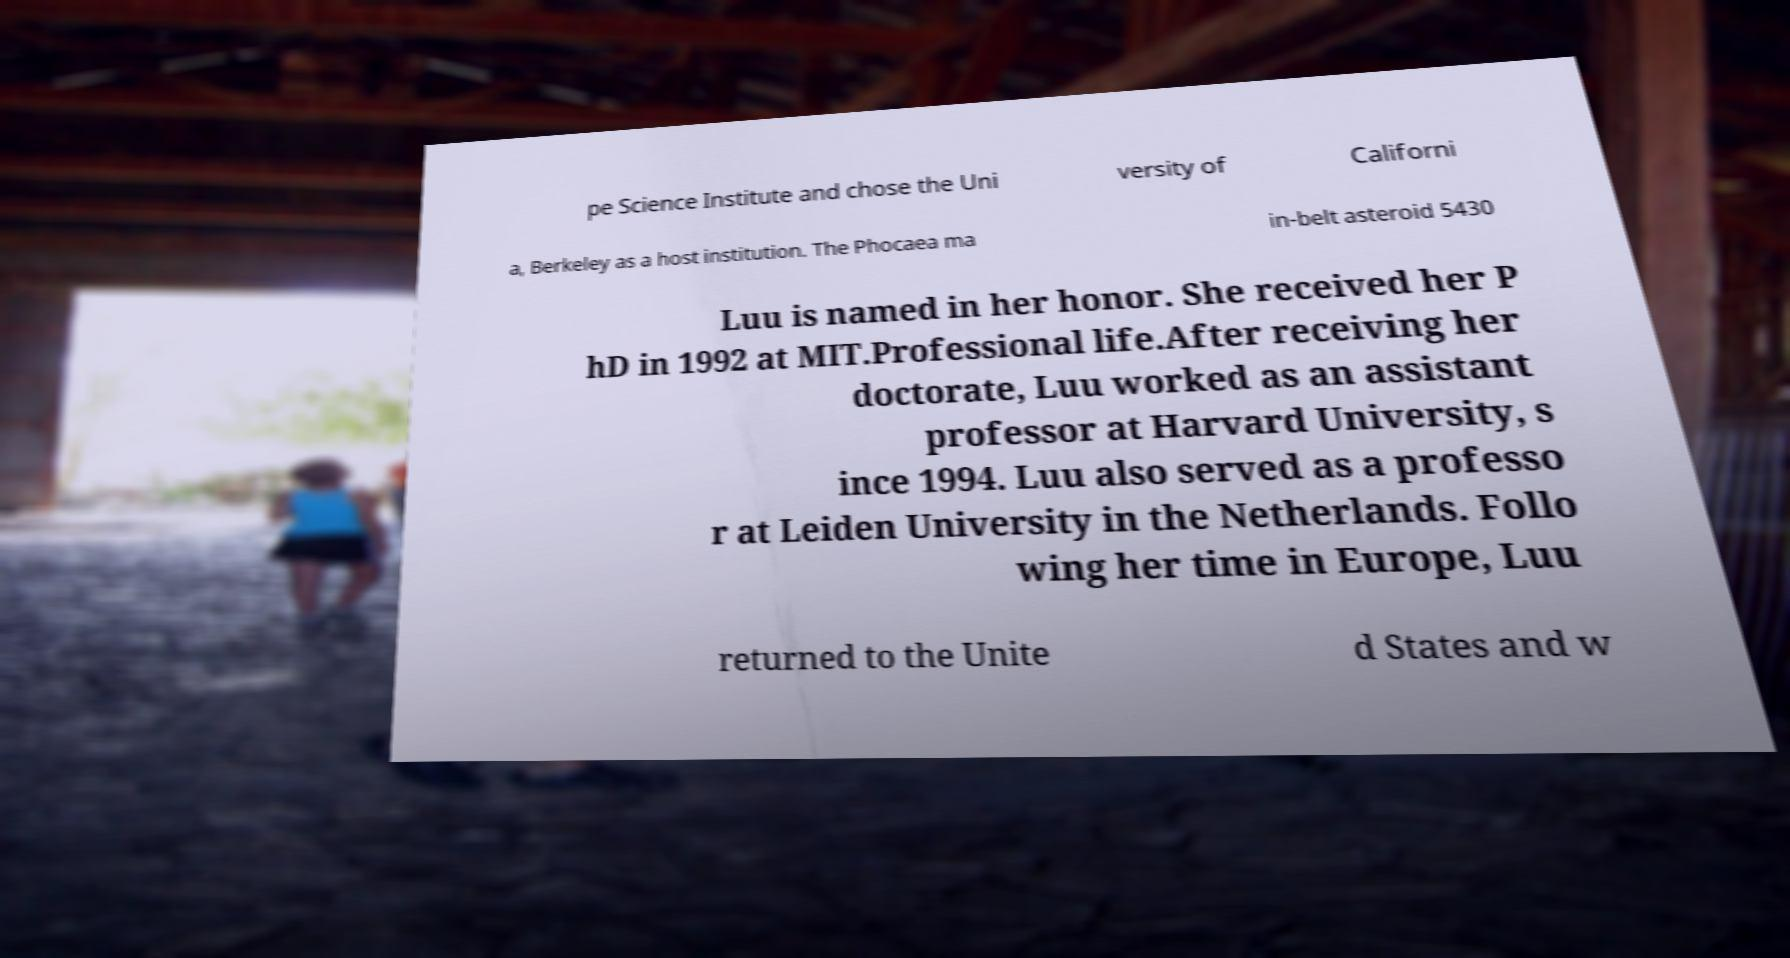Please identify and transcribe the text found in this image. pe Science Institute and chose the Uni versity of Californi a, Berkeley as a host institution. The Phocaea ma in-belt asteroid 5430 Luu is named in her honor. She received her P hD in 1992 at MIT.Professional life.After receiving her doctorate, Luu worked as an assistant professor at Harvard University, s ince 1994. Luu also served as a professo r at Leiden University in the Netherlands. Follo wing her time in Europe, Luu returned to the Unite d States and w 